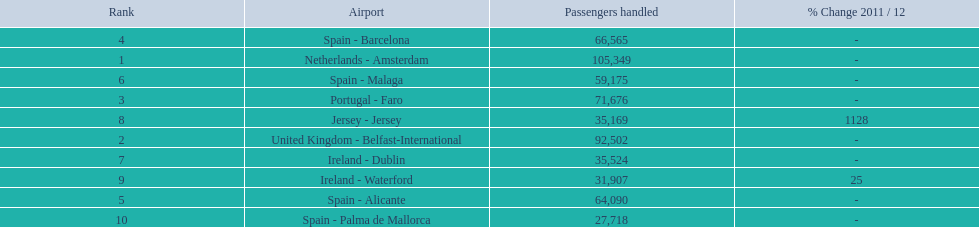Name all the london southend airports that did not list a change in 2001/12. Netherlands - Amsterdam, United Kingdom - Belfast-International, Portugal - Faro, Spain - Barcelona, Spain - Alicante, Spain - Malaga, Ireland - Dublin, Spain - Palma de Mallorca. What unchanged percentage airports from 2011/12 handled less then 50,000 passengers? Ireland - Dublin, Spain - Palma de Mallorca. What unchanged percentage airport from 2011/12 handled less then 50,000 passengers is the closest to the equator? Spain - Palma de Mallorca. 